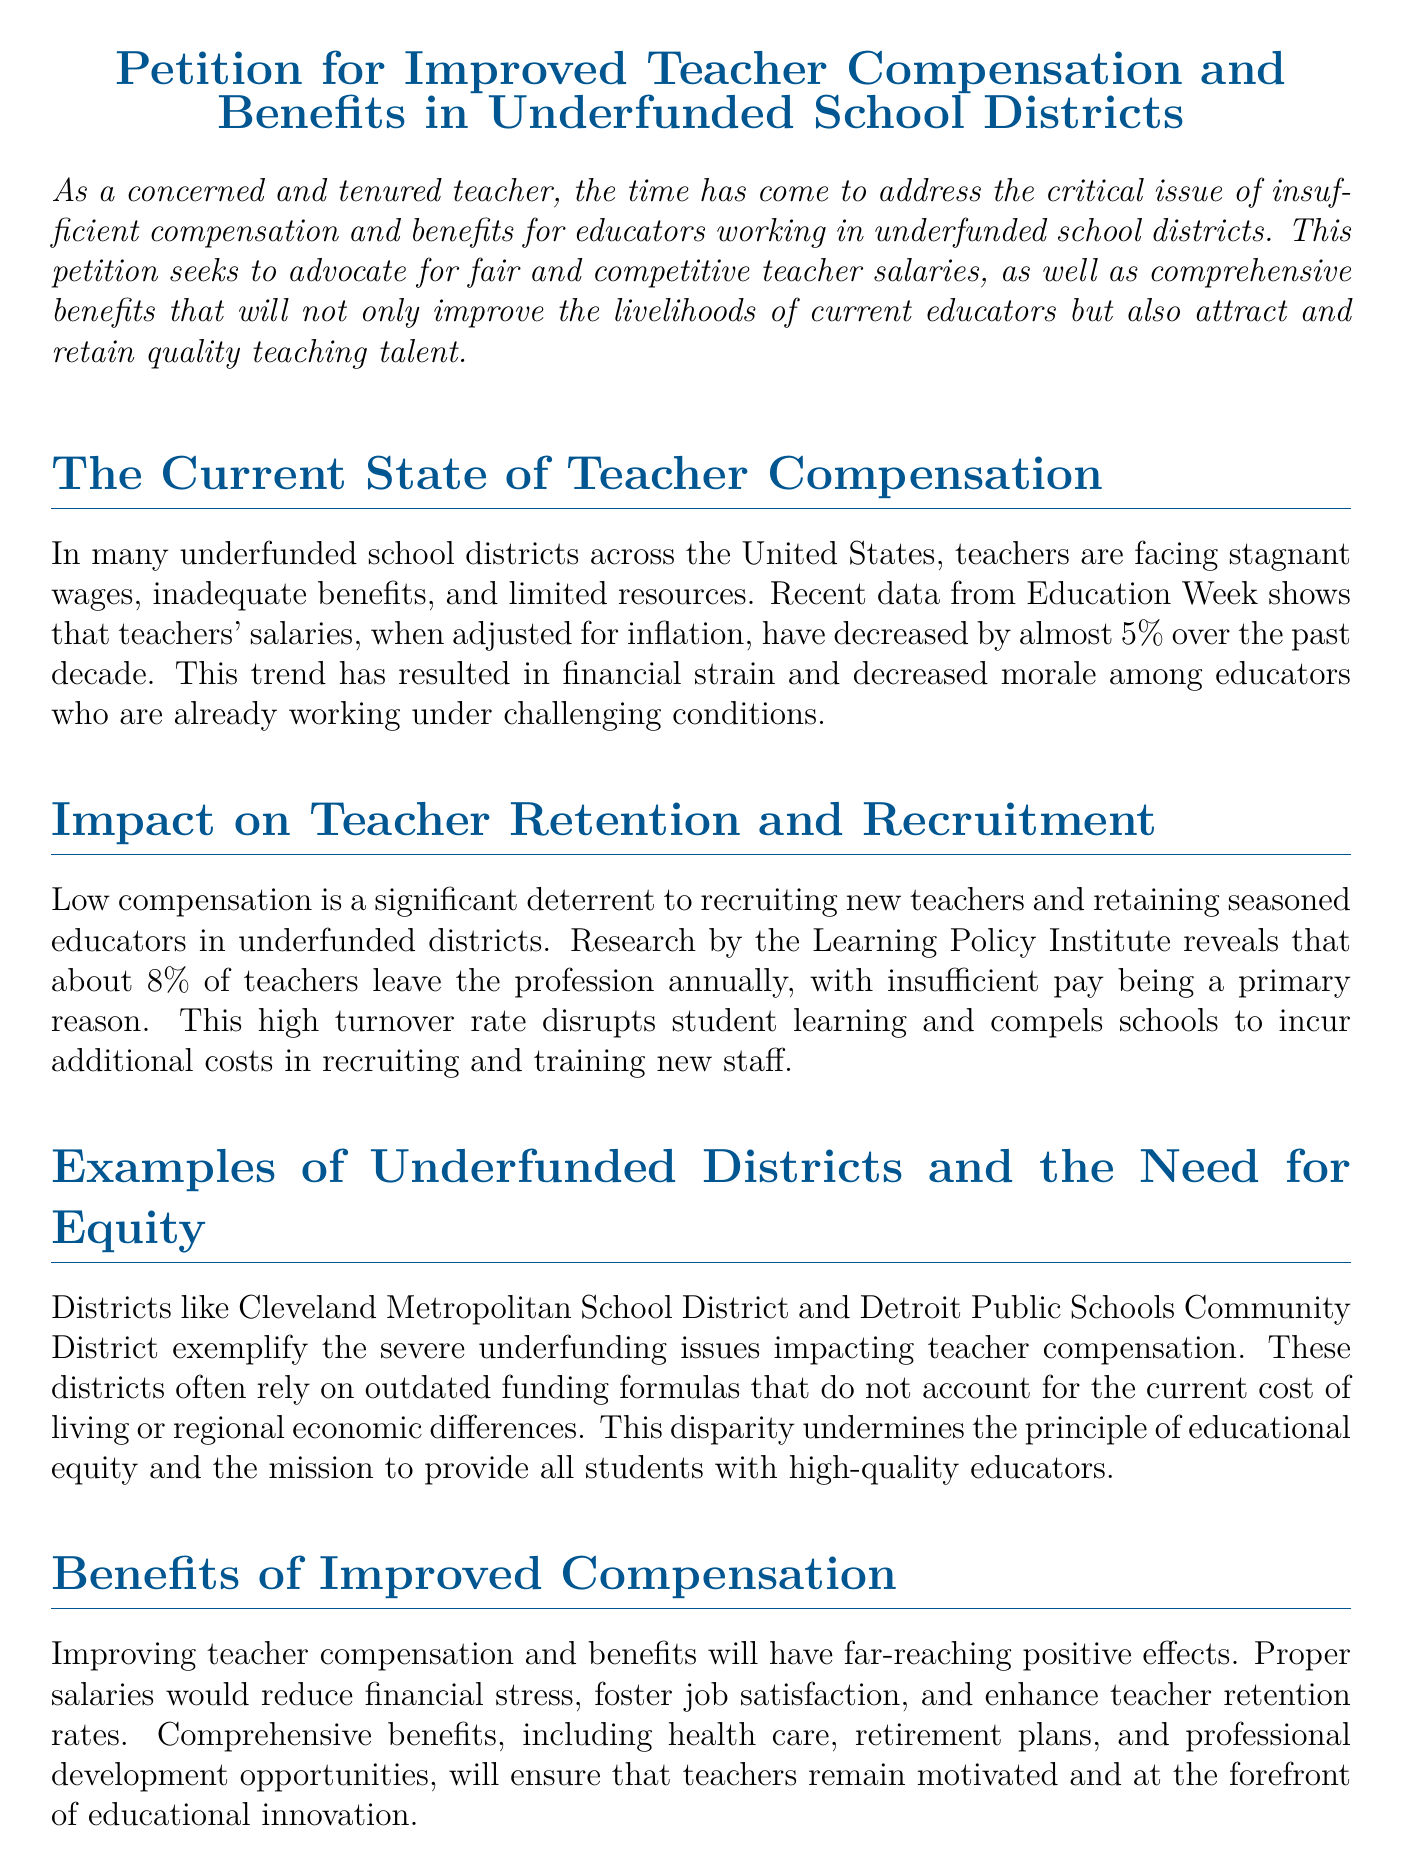What is the main goal of the petition? The petition aims to advocate for fair and competitive teacher salaries and comprehensive benefits.
Answer: Fair and competitive teacher salaries and comprehensive benefits What percentage of teachers leave the profession annually? The document states that about 8% of teachers leave the profession every year.
Answer: 8% Which two school districts are given as examples of underfunded districts? The document mentions Cleveland Metropolitan School District and Detroit Public Schools Community District.
Answer: Cleveland Metropolitan School District and Detroit Public Schools Community District What trend has been observed in teachers' salaries over the past decade? Teachers' salaries, when adjusted for inflation, have decreased by almost 5%.
Answer: Decreased by almost 5% What are some of the benefits of improved teacher compensation listed in the document? Improved teacher compensation can reduce financial stress and enhance teacher retention rates.
Answer: Reduce financial stress and enhance teacher retention rates What does the petition urge lawmakers to prioritize? The petition urges increased funding for underfunded school districts.
Answer: Increased funding for underfunded school districts What is a major reason mentioned for the high turnover rate of teachers? Insufficient pay is cited as a primary reason for the high turnover rate among teachers.
Answer: Insufficient pay What type of document is this? The document is a petition addressing issues related to teacher compensation in underfunded districts.
Answer: Petition 